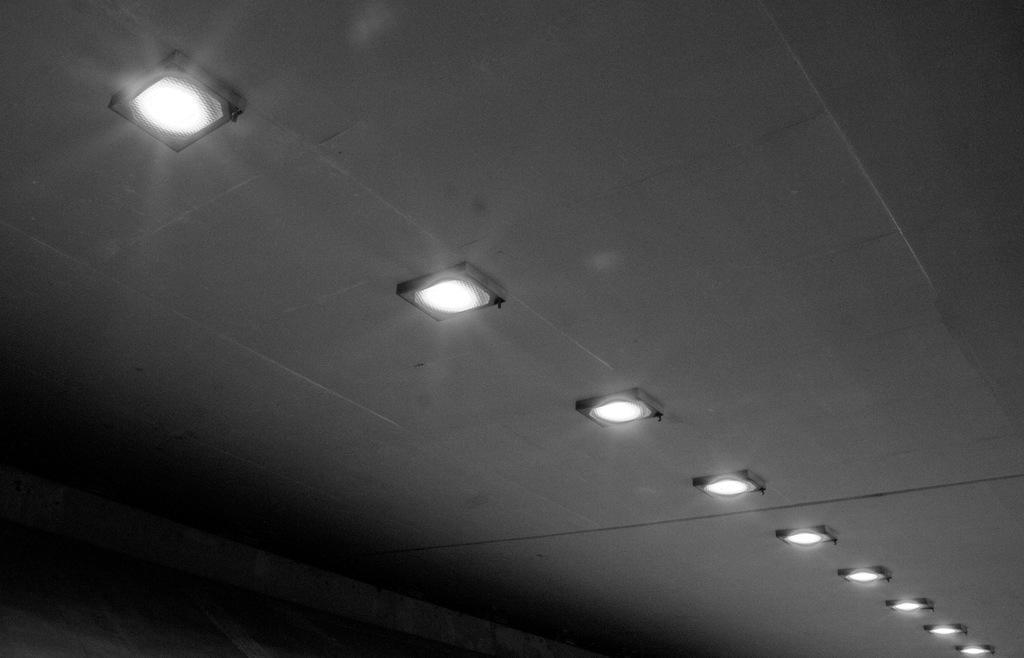Could you give a brief overview of what you see in this image? In this image we can see the inner view of a building and it looks like a ceiling with lights. 